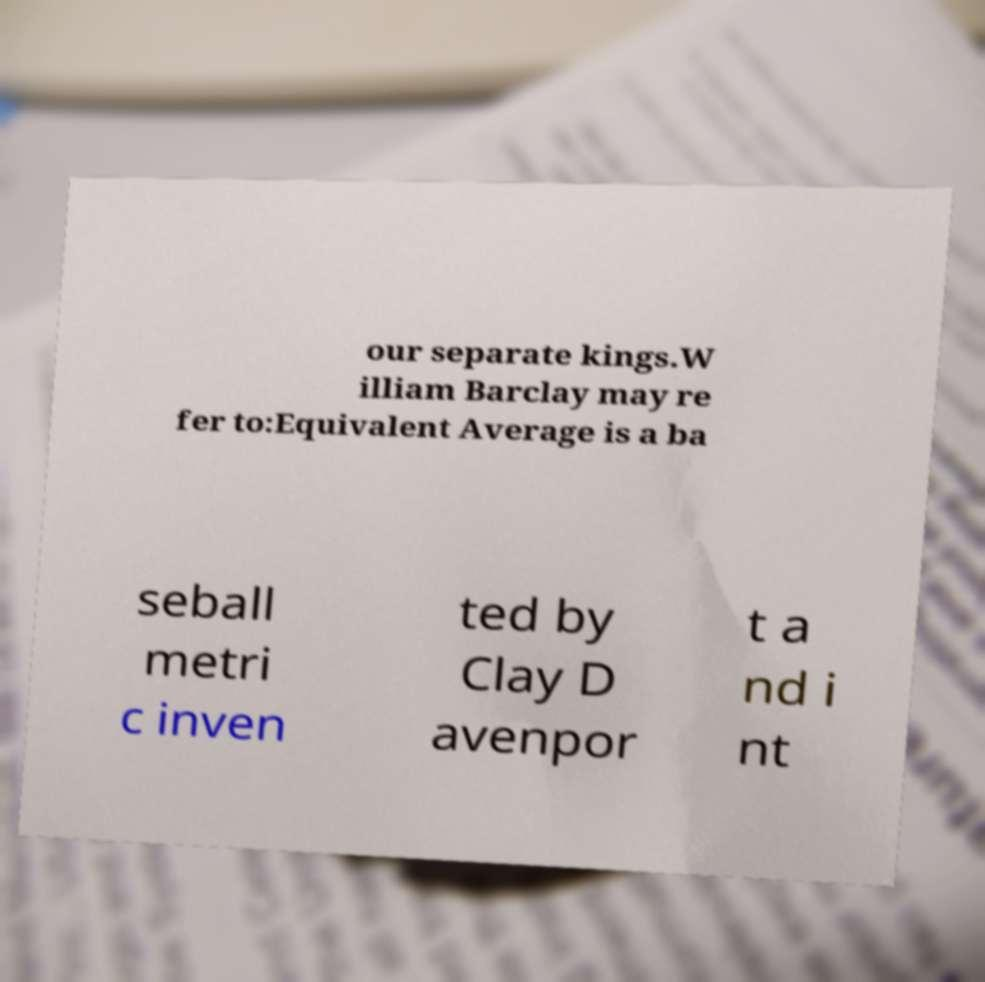What messages or text are displayed in this image? I need them in a readable, typed format. our separate kings.W illiam Barclay may re fer to:Equivalent Average is a ba seball metri c inven ted by Clay D avenpor t a nd i nt 